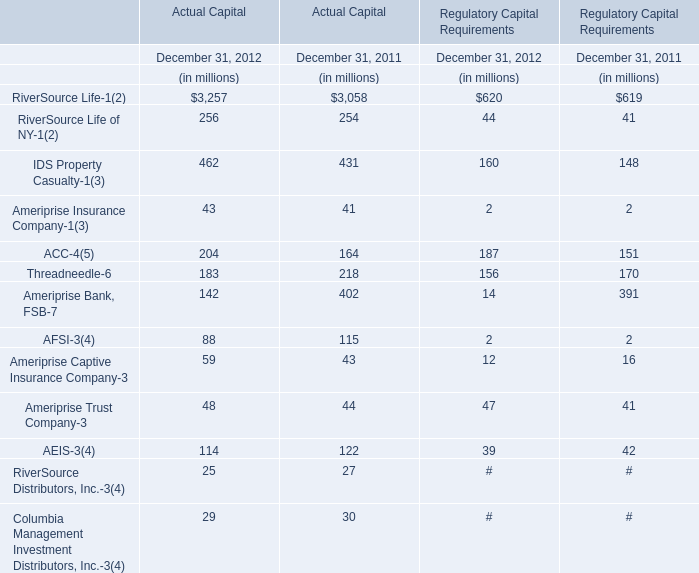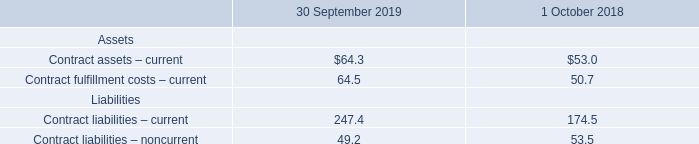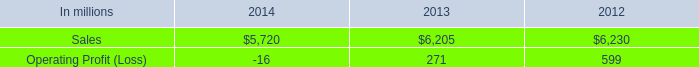What's the growth rate of RiverSource Life-1 of Actual Capital in 2012? 
Computations: ((3257 - 3058) / 3058)
Answer: 0.06508. 